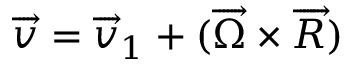<formula> <loc_0><loc_0><loc_500><loc_500>\overrightarrow { v } = \overrightarrow { v } _ { 1 } + ( \overrightarrow { \Omega } \times \overrightarrow { R } )</formula> 